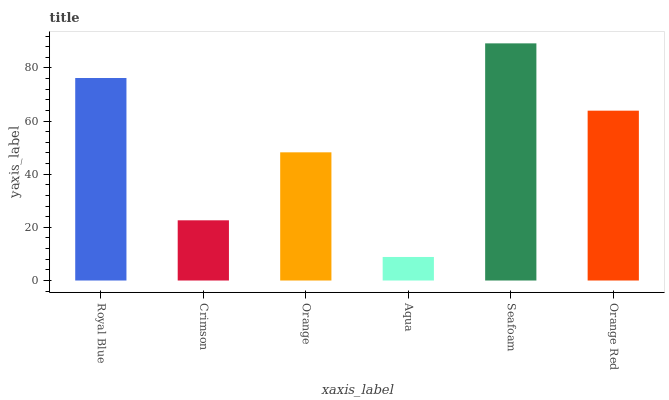Is Aqua the minimum?
Answer yes or no. Yes. Is Seafoam the maximum?
Answer yes or no. Yes. Is Crimson the minimum?
Answer yes or no. No. Is Crimson the maximum?
Answer yes or no. No. Is Royal Blue greater than Crimson?
Answer yes or no. Yes. Is Crimson less than Royal Blue?
Answer yes or no. Yes. Is Crimson greater than Royal Blue?
Answer yes or no. No. Is Royal Blue less than Crimson?
Answer yes or no. No. Is Orange Red the high median?
Answer yes or no. Yes. Is Orange the low median?
Answer yes or no. Yes. Is Royal Blue the high median?
Answer yes or no. No. Is Seafoam the low median?
Answer yes or no. No. 